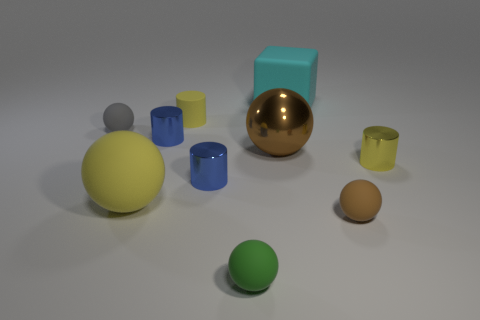Subtract all metallic cylinders. How many cylinders are left? 1 Subtract all green balls. How many balls are left? 4 Subtract all red balls. Subtract all blue cylinders. How many balls are left? 5 Subtract all cylinders. How many objects are left? 6 Add 2 yellow cubes. How many yellow cubes exist? 2 Subtract 1 yellow balls. How many objects are left? 9 Subtract all tiny red cubes. Subtract all small brown spheres. How many objects are left? 9 Add 6 tiny green matte balls. How many tiny green matte balls are left? 7 